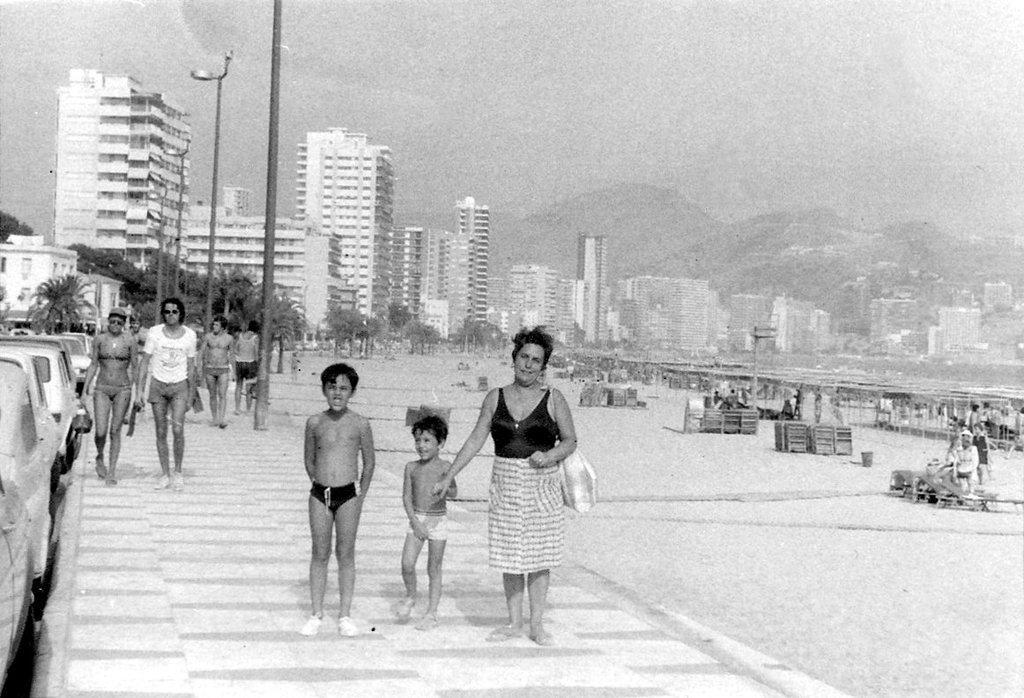Can you describe this image briefly? It is the black and white image in which there are few people walking on the footpath. Beside the footpath there are cars parked on the road. In the background there are buildings. On the footpath there are poles. On the right side there is sand. In the sand there are so many people. 